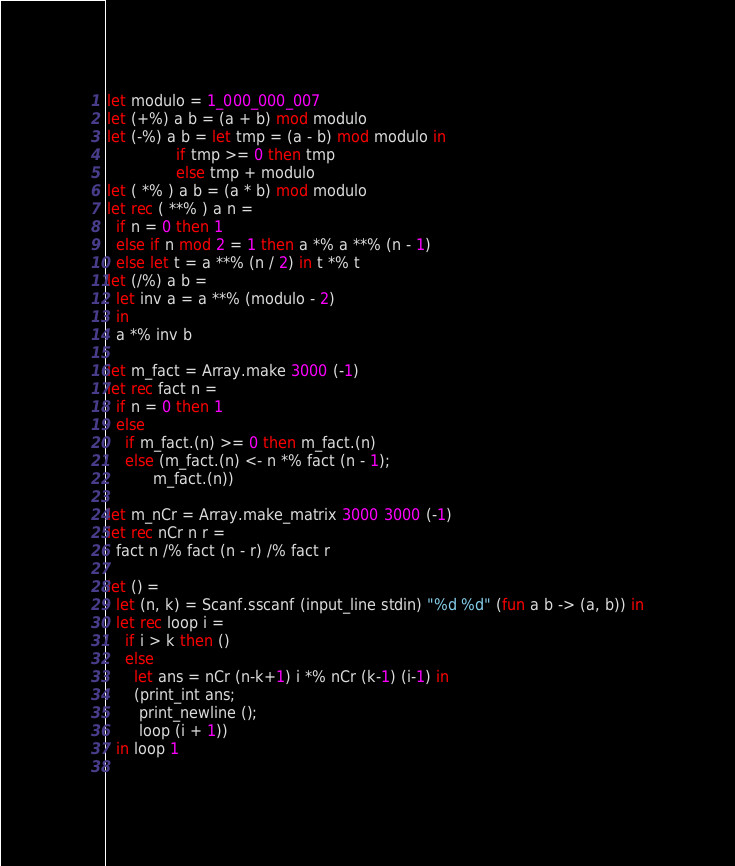Convert code to text. <code><loc_0><loc_0><loc_500><loc_500><_OCaml_>let modulo = 1_000_000_007
let (+%) a b = (a + b) mod modulo
let (-%) a b = let tmp = (a - b) mod modulo in
               if tmp >= 0 then tmp
               else tmp + modulo
let ( *% ) a b = (a * b) mod modulo
let rec ( **% ) a n =
  if n = 0 then 1
  else if n mod 2 = 1 then a *% a **% (n - 1)
  else let t = a **% (n / 2) in t *% t
let (/%) a b =
  let inv a = a **% (modulo - 2)
  in
  a *% inv b

let m_fact = Array.make 3000 (-1)
let rec fact n =
  if n = 0 then 1
  else
    if m_fact.(n) >= 0 then m_fact.(n)
    else (m_fact.(n) <- n *% fact (n - 1);
          m_fact.(n))
  
let m_nCr = Array.make_matrix 3000 3000 (-1)
let rec nCr n r =
  fact n /% fact (n - r) /% fact r
  
let () =
  let (n, k) = Scanf.sscanf (input_line stdin) "%d %d" (fun a b -> (a, b)) in
  let rec loop i =
    if i > k then ()
    else
      let ans = nCr (n-k+1) i *% nCr (k-1) (i-1) in
      (print_int ans;
       print_newline ();
       loop (i + 1))
  in loop 1
    
</code> 